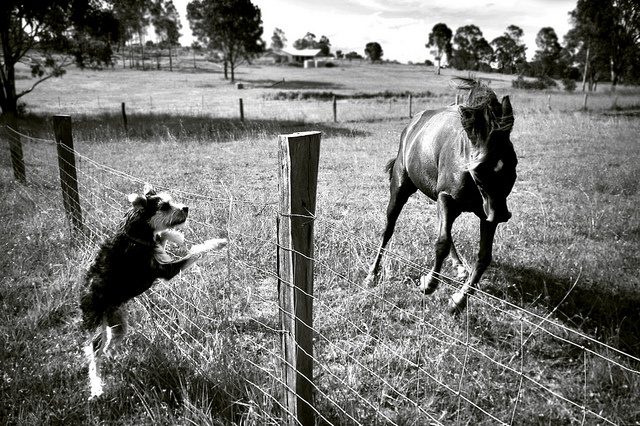Describe the objects in this image and their specific colors. I can see horse in black, darkgray, lightgray, and gray tones and dog in black, gray, darkgray, and lightgray tones in this image. 